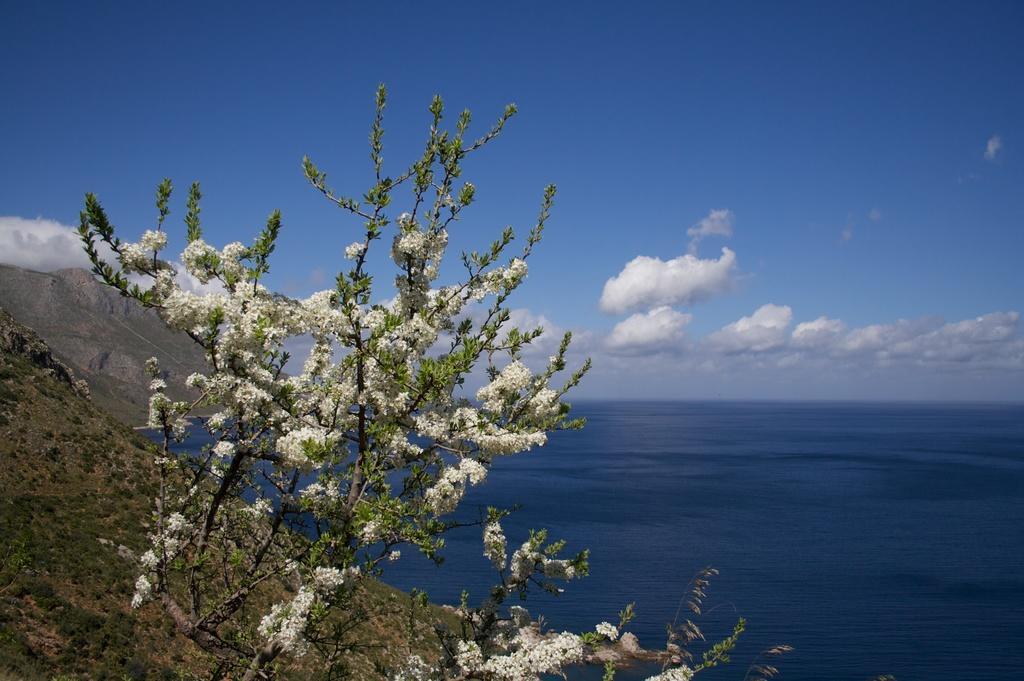Describe this image in one or two sentences. There are some plants with flowers at the bottom of this image and there are some mountains on the left side of this image. There is a surface of water on the right side of this image, and there is a sky at the top of this image. 